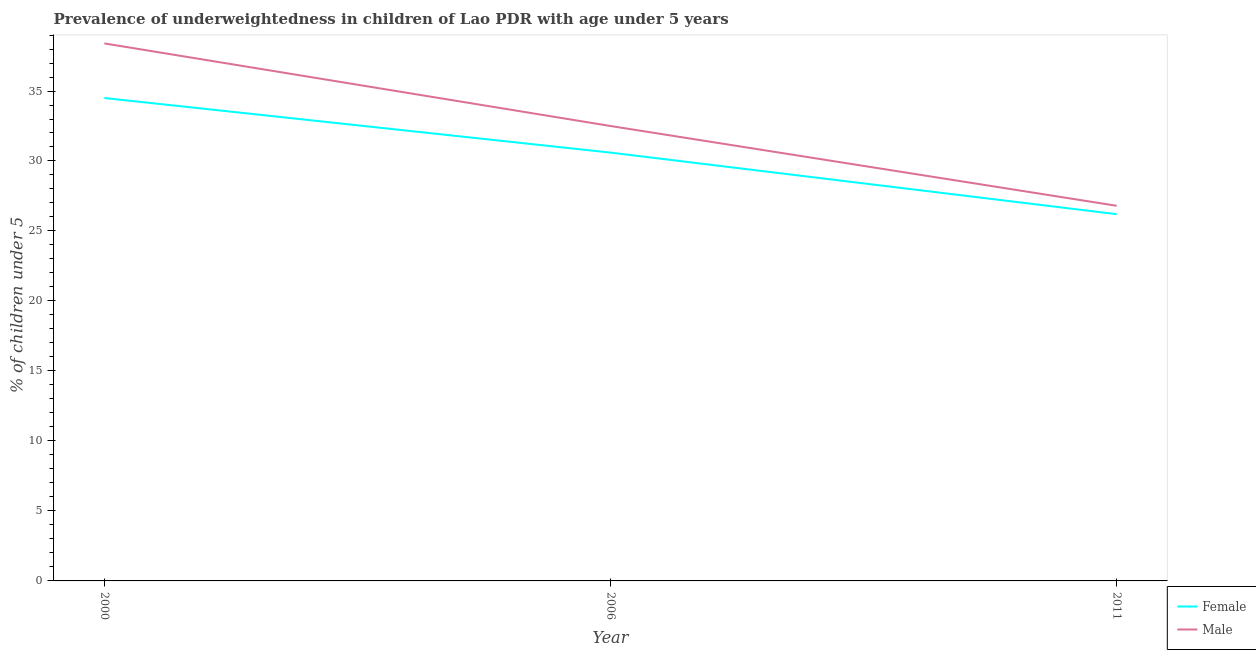Does the line corresponding to percentage of underweighted male children intersect with the line corresponding to percentage of underweighted female children?
Give a very brief answer. No. What is the percentage of underweighted female children in 2006?
Make the answer very short. 30.6. Across all years, what is the maximum percentage of underweighted male children?
Provide a succinct answer. 38.4. Across all years, what is the minimum percentage of underweighted female children?
Give a very brief answer. 26.2. What is the total percentage of underweighted male children in the graph?
Your answer should be very brief. 97.7. What is the difference between the percentage of underweighted female children in 2000 and that in 2011?
Ensure brevity in your answer.  8.3. What is the difference between the percentage of underweighted female children in 2011 and the percentage of underweighted male children in 2006?
Provide a succinct answer. -6.3. What is the average percentage of underweighted male children per year?
Your answer should be very brief. 32.57. In the year 2011, what is the difference between the percentage of underweighted male children and percentage of underweighted female children?
Provide a succinct answer. 0.6. In how many years, is the percentage of underweighted female children greater than 38 %?
Offer a very short reply. 0. What is the ratio of the percentage of underweighted male children in 2000 to that in 2011?
Offer a very short reply. 1.43. What is the difference between the highest and the second highest percentage of underweighted female children?
Make the answer very short. 3.9. What is the difference between the highest and the lowest percentage of underweighted male children?
Provide a short and direct response. 11.6. In how many years, is the percentage of underweighted male children greater than the average percentage of underweighted male children taken over all years?
Your response must be concise. 1. Is the sum of the percentage of underweighted female children in 2006 and 2011 greater than the maximum percentage of underweighted male children across all years?
Give a very brief answer. Yes. Is the percentage of underweighted female children strictly greater than the percentage of underweighted male children over the years?
Keep it short and to the point. No. Is the percentage of underweighted female children strictly less than the percentage of underweighted male children over the years?
Your answer should be very brief. Yes. What is the difference between two consecutive major ticks on the Y-axis?
Make the answer very short. 5. Does the graph contain any zero values?
Offer a terse response. No. Does the graph contain grids?
Ensure brevity in your answer.  No. How many legend labels are there?
Your response must be concise. 2. How are the legend labels stacked?
Offer a terse response. Vertical. What is the title of the graph?
Make the answer very short. Prevalence of underweightedness in children of Lao PDR with age under 5 years. Does "Money lenders" appear as one of the legend labels in the graph?
Provide a short and direct response. No. What is the label or title of the X-axis?
Keep it short and to the point. Year. What is the label or title of the Y-axis?
Your response must be concise.  % of children under 5. What is the  % of children under 5 in Female in 2000?
Keep it short and to the point. 34.5. What is the  % of children under 5 of Male in 2000?
Your response must be concise. 38.4. What is the  % of children under 5 of Female in 2006?
Offer a very short reply. 30.6. What is the  % of children under 5 in Male in 2006?
Provide a short and direct response. 32.5. What is the  % of children under 5 in Female in 2011?
Your answer should be compact. 26.2. What is the  % of children under 5 of Male in 2011?
Your answer should be compact. 26.8. Across all years, what is the maximum  % of children under 5 of Female?
Your response must be concise. 34.5. Across all years, what is the maximum  % of children under 5 in Male?
Keep it short and to the point. 38.4. Across all years, what is the minimum  % of children under 5 of Female?
Your answer should be very brief. 26.2. Across all years, what is the minimum  % of children under 5 of Male?
Provide a succinct answer. 26.8. What is the total  % of children under 5 of Female in the graph?
Your answer should be very brief. 91.3. What is the total  % of children under 5 of Male in the graph?
Make the answer very short. 97.7. What is the difference between the  % of children under 5 of Male in 2000 and that in 2006?
Your response must be concise. 5.9. What is the difference between the  % of children under 5 in Male in 2000 and that in 2011?
Keep it short and to the point. 11.6. What is the difference between the  % of children under 5 in Female in 2006 and that in 2011?
Offer a terse response. 4.4. What is the difference between the  % of children under 5 in Female in 2000 and the  % of children under 5 in Male in 2006?
Make the answer very short. 2. What is the difference between the  % of children under 5 in Female in 2000 and the  % of children under 5 in Male in 2011?
Your answer should be compact. 7.7. What is the difference between the  % of children under 5 of Female in 2006 and the  % of children under 5 of Male in 2011?
Offer a very short reply. 3.8. What is the average  % of children under 5 in Female per year?
Give a very brief answer. 30.43. What is the average  % of children under 5 in Male per year?
Offer a terse response. 32.57. What is the ratio of the  % of children under 5 in Female in 2000 to that in 2006?
Give a very brief answer. 1.13. What is the ratio of the  % of children under 5 in Male in 2000 to that in 2006?
Give a very brief answer. 1.18. What is the ratio of the  % of children under 5 of Female in 2000 to that in 2011?
Provide a succinct answer. 1.32. What is the ratio of the  % of children under 5 in Male in 2000 to that in 2011?
Offer a terse response. 1.43. What is the ratio of the  % of children under 5 of Female in 2006 to that in 2011?
Keep it short and to the point. 1.17. What is the ratio of the  % of children under 5 of Male in 2006 to that in 2011?
Provide a succinct answer. 1.21. What is the difference between the highest and the second highest  % of children under 5 in Male?
Ensure brevity in your answer.  5.9. 